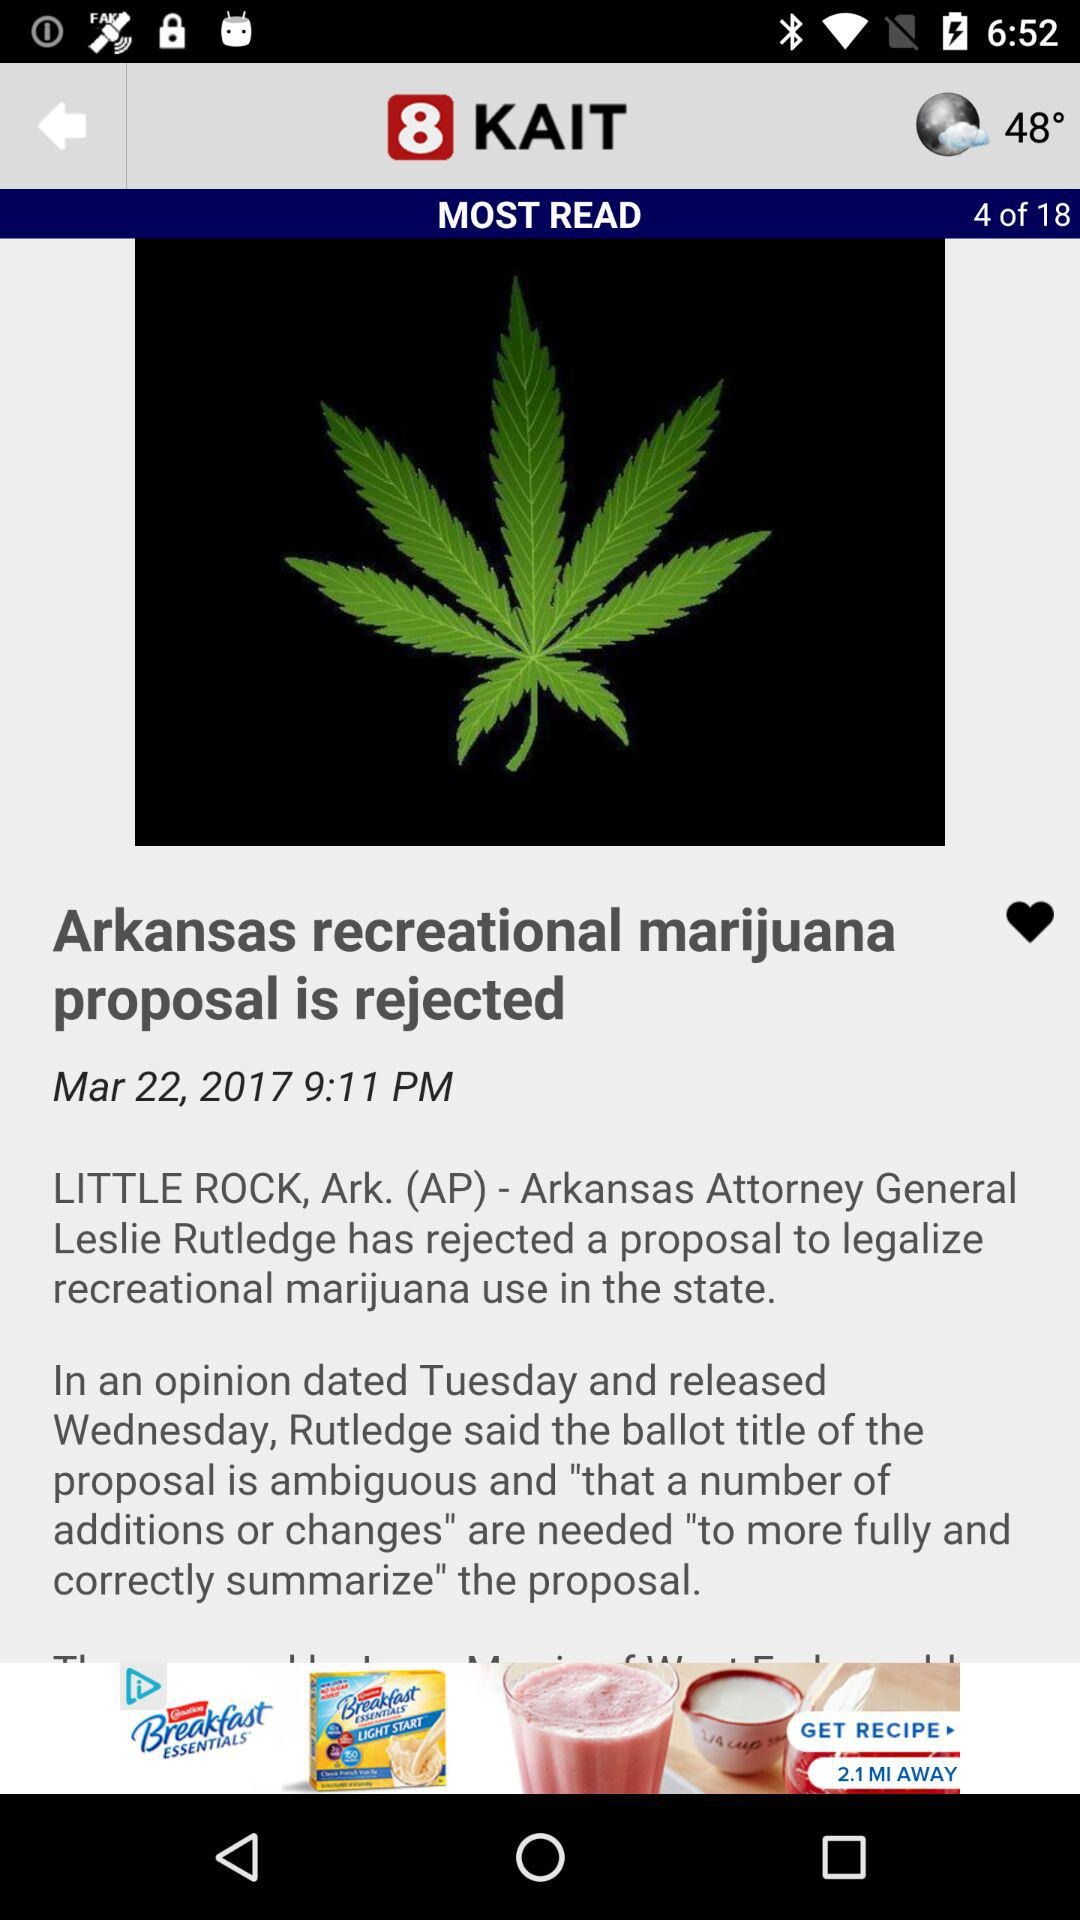What is the publication time of this article? The publication time is 9:11 PM. 